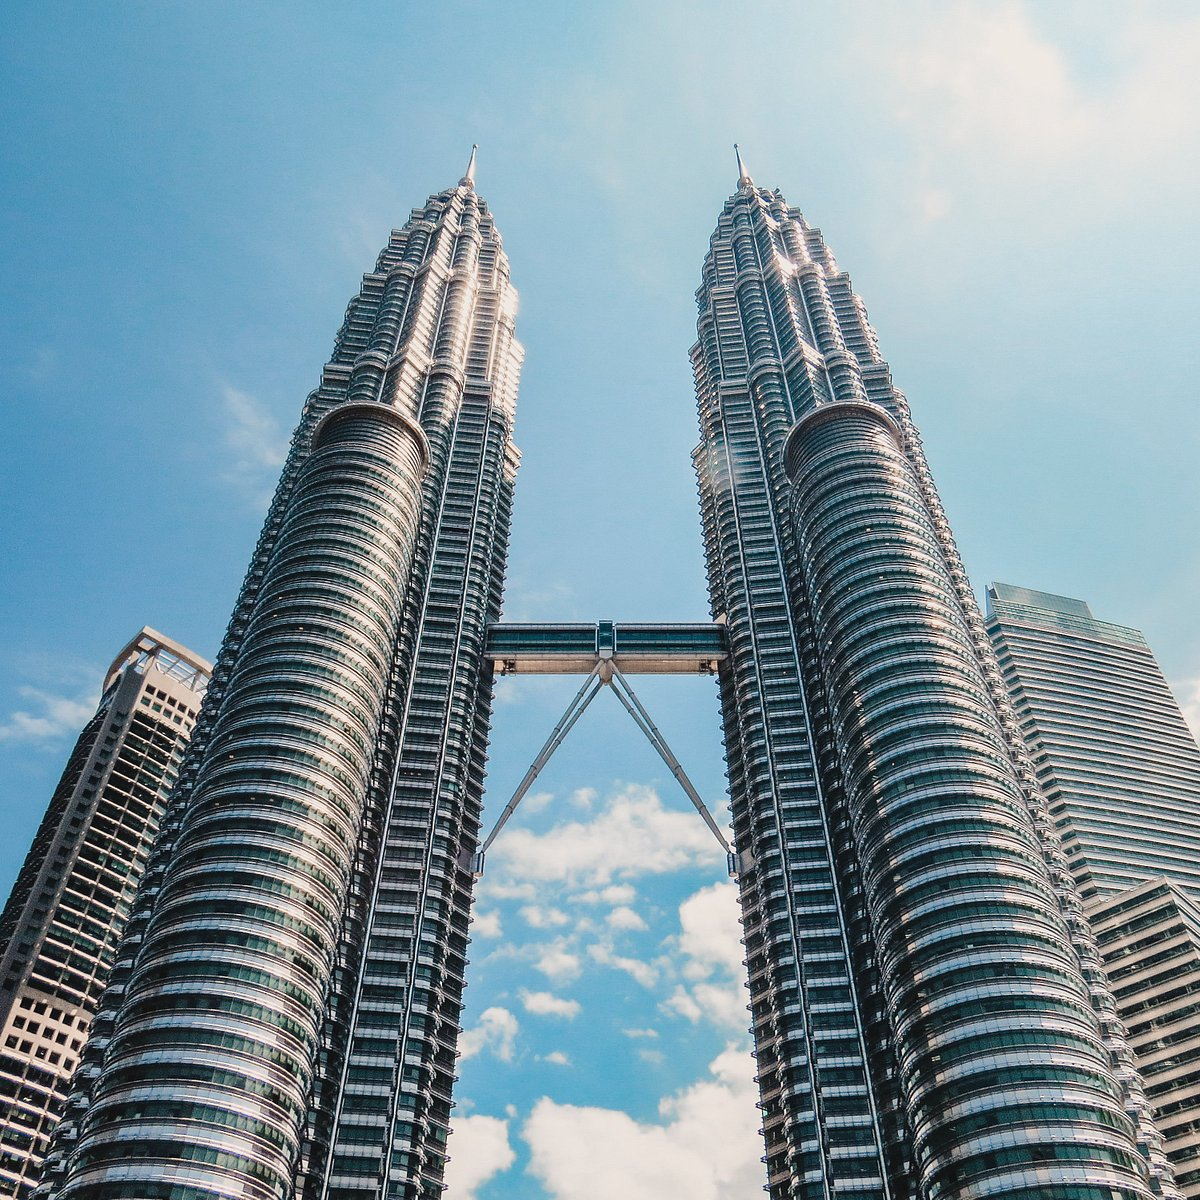Can you explain the architectural significance of the Petronas Twin Towers? The Petronas Twin Towers are exemplary of postmodern architecture blended with Islamic design elements, which is significant as it mirrors Malaysia's cultural heritage. Each tower has 88 floors, and the design includes steel and glass facades patterned after traditional Islamic art motifs, which promote natural light while reflecting the tropical sunlight. The skybridge linking the two towers symbolizes a gateway to the future and is an innovative solution to the need for inter-tower connectivity, enhancing both the functionality and the aesthetic appeal of the entire structure. 